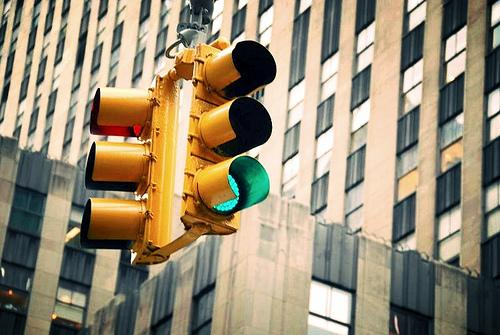Question: what color is the light facing left on?
Choices:
A. Green.
B. Yellow.
C. Red.
D. Orange.
Answer with the letter. Answer: C Question: how many people are in the photo?
Choices:
A. 1.
B. 2.
C. 3.
D. 0.
Answer with the letter. Answer: D Question: how many cats are on top of the building?
Choices:
A. 1.
B. 2.
C. 0.
D. 3.
Answer with the letter. Answer: C 